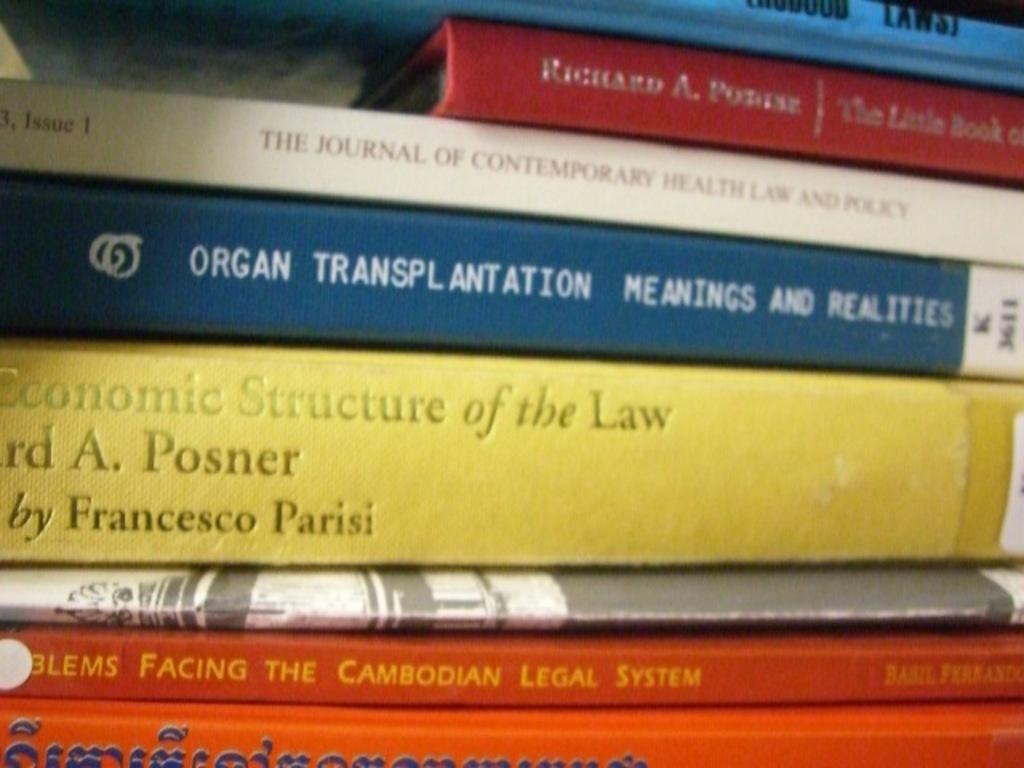<image>
Give a short and clear explanation of the subsequent image. A stack of books with one title Organ Transplantation. 